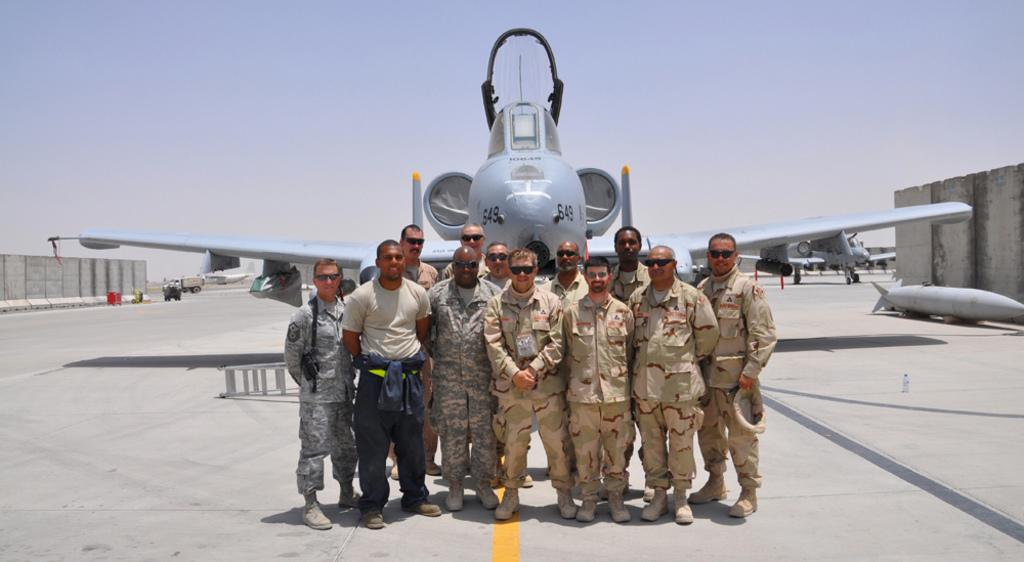What is happening in the middle of the image? There are people standing in the middle of the image. What is the facial expression of the people in the image? The people are smiling. What type of transportation can be seen in the image? Planes and vehicles are visible in the image. What type of structures are present in the image? There are walls in the image. What is visible at the top of the image? Clouds and the sky are visible at the top of the image. What type of pencil can be seen in the image? There is no pencil present in the image. What angle is the picture taken from? The angle from which the image is taken cannot be determined from the image itself. 